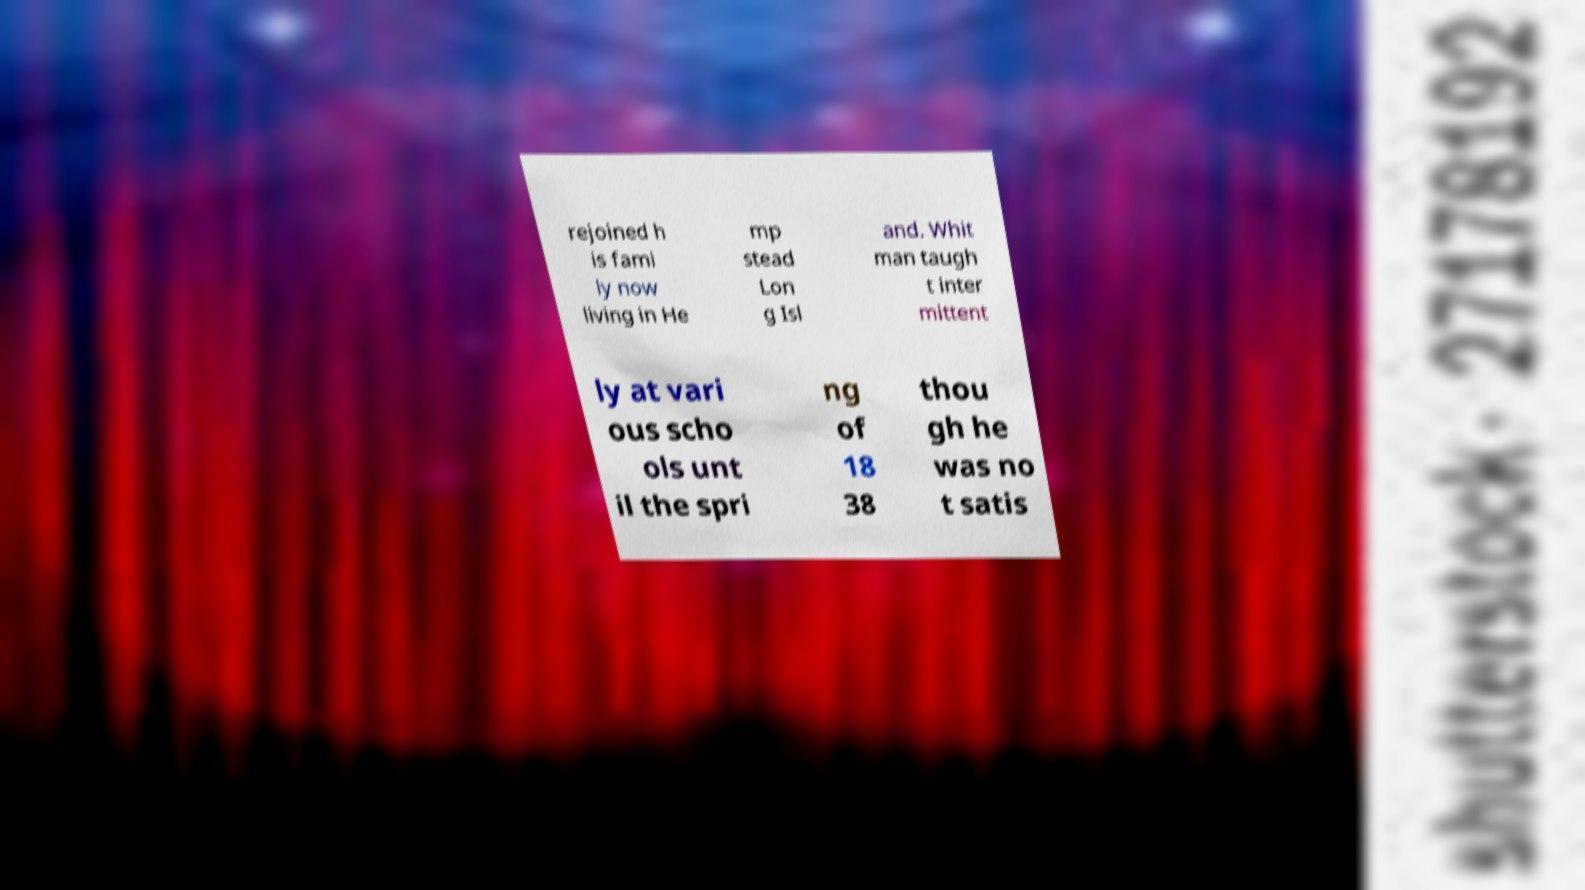Could you assist in decoding the text presented in this image and type it out clearly? rejoined h is fami ly now living in He mp stead Lon g Isl and. Whit man taugh t inter mittent ly at vari ous scho ols unt il the spri ng of 18 38 thou gh he was no t satis 